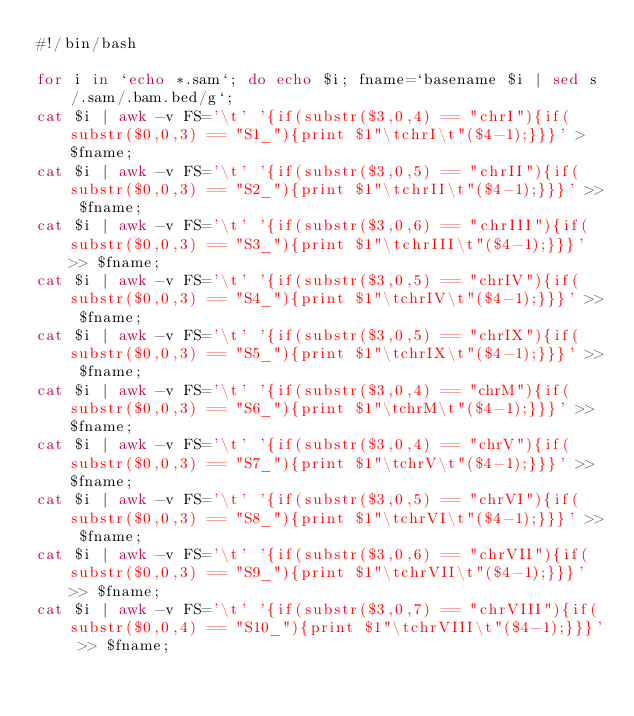<code> <loc_0><loc_0><loc_500><loc_500><_Bash_>#!/bin/bash

for i in `echo *.sam`; do echo $i; fname=`basename $i | sed s/.sam/.bam.bed/g`;
cat $i | awk -v FS='\t' '{if(substr($3,0,4) == "chrI"){if(substr($0,0,3) == "S1_"){print $1"\tchrI\t"($4-1);}}}' > $fname;
cat $i | awk -v FS='\t' '{if(substr($3,0,5) == "chrII"){if(substr($0,0,3) == "S2_"){print $1"\tchrII\t"($4-1);}}}' >> $fname;
cat $i | awk -v FS='\t' '{if(substr($3,0,6) == "chrIII"){if(substr($0,0,3) == "S3_"){print $1"\tchrIII\t"($4-1);}}}' >> $fname;
cat $i | awk -v FS='\t' '{if(substr($3,0,5) == "chrIV"){if(substr($0,0,3) == "S4_"){print $1"\tchrIV\t"($4-1);}}}' >> $fname;
cat $i | awk -v FS='\t' '{if(substr($3,0,5) == "chrIX"){if(substr($0,0,3) == "S5_"){print $1"\tchrIX\t"($4-1);}}}' >> $fname;
cat $i | awk -v FS='\t' '{if(substr($3,0,4) == "chrM"){if(substr($0,0,3) == "S6_"){print $1"\tchrM\t"($4-1);}}}' >> $fname;
cat $i | awk -v FS='\t' '{if(substr($3,0,4) == "chrV"){if(substr($0,0,3) == "S7_"){print $1"\tchrV\t"($4-1);}}}' >> $fname;
cat $i | awk -v FS='\t' '{if(substr($3,0,5) == "chrVI"){if(substr($0,0,3) == "S8_"){print $1"\tchrVI\t"($4-1);}}}' >> $fname;
cat $i | awk -v FS='\t' '{if(substr($3,0,6) == "chrVII"){if(substr($0,0,3) == "S9_"){print $1"\tchrVII\t"($4-1);}}}' >> $fname;
cat $i | awk -v FS='\t' '{if(substr($3,0,7) == "chrVIII"){if(substr($0,0,4) == "S10_"){print $1"\tchrVIII\t"($4-1);}}}' >> $fname;</code> 